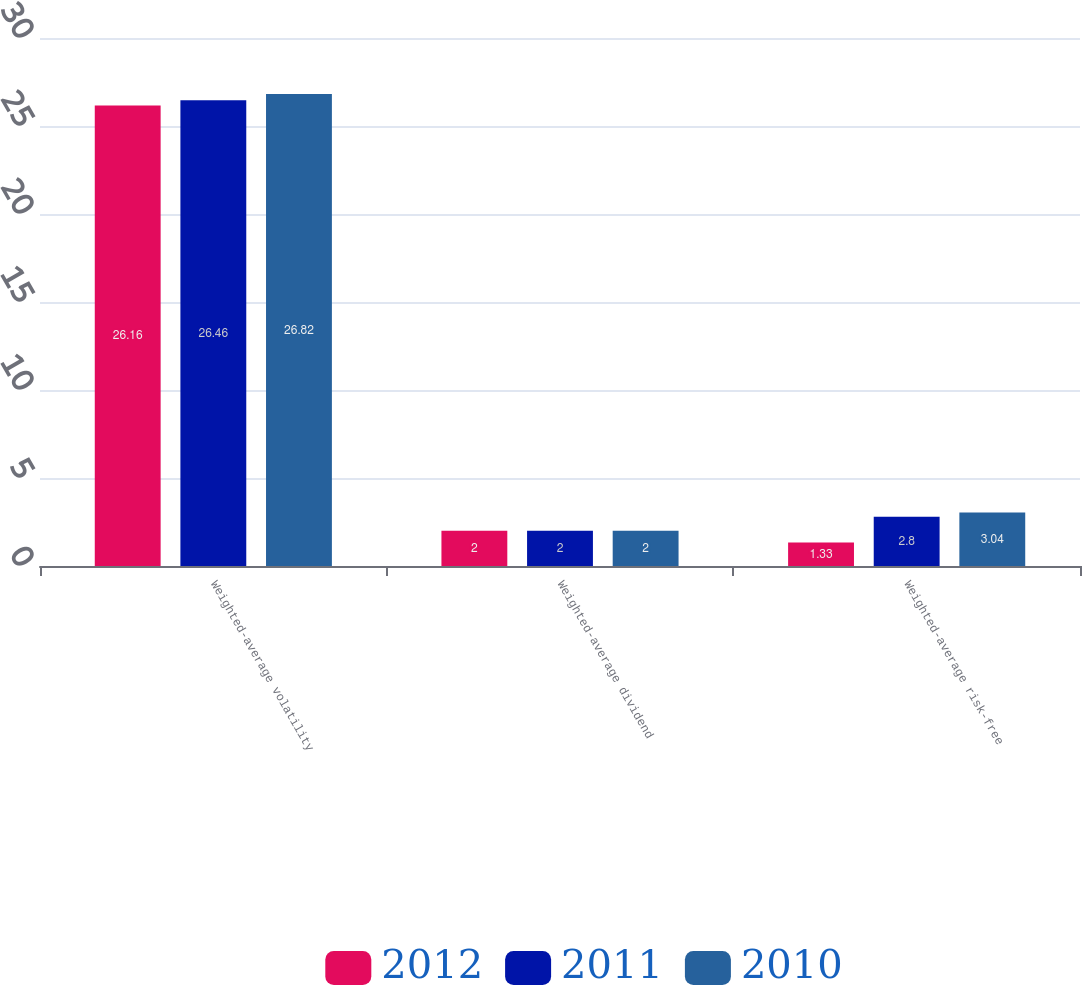Convert chart to OTSL. <chart><loc_0><loc_0><loc_500><loc_500><stacked_bar_chart><ecel><fcel>Weighted-average volatility<fcel>Weighted-average dividend<fcel>Weighted-average risk-free<nl><fcel>2012<fcel>26.16<fcel>2<fcel>1.33<nl><fcel>2011<fcel>26.46<fcel>2<fcel>2.8<nl><fcel>2010<fcel>26.82<fcel>2<fcel>3.04<nl></chart> 